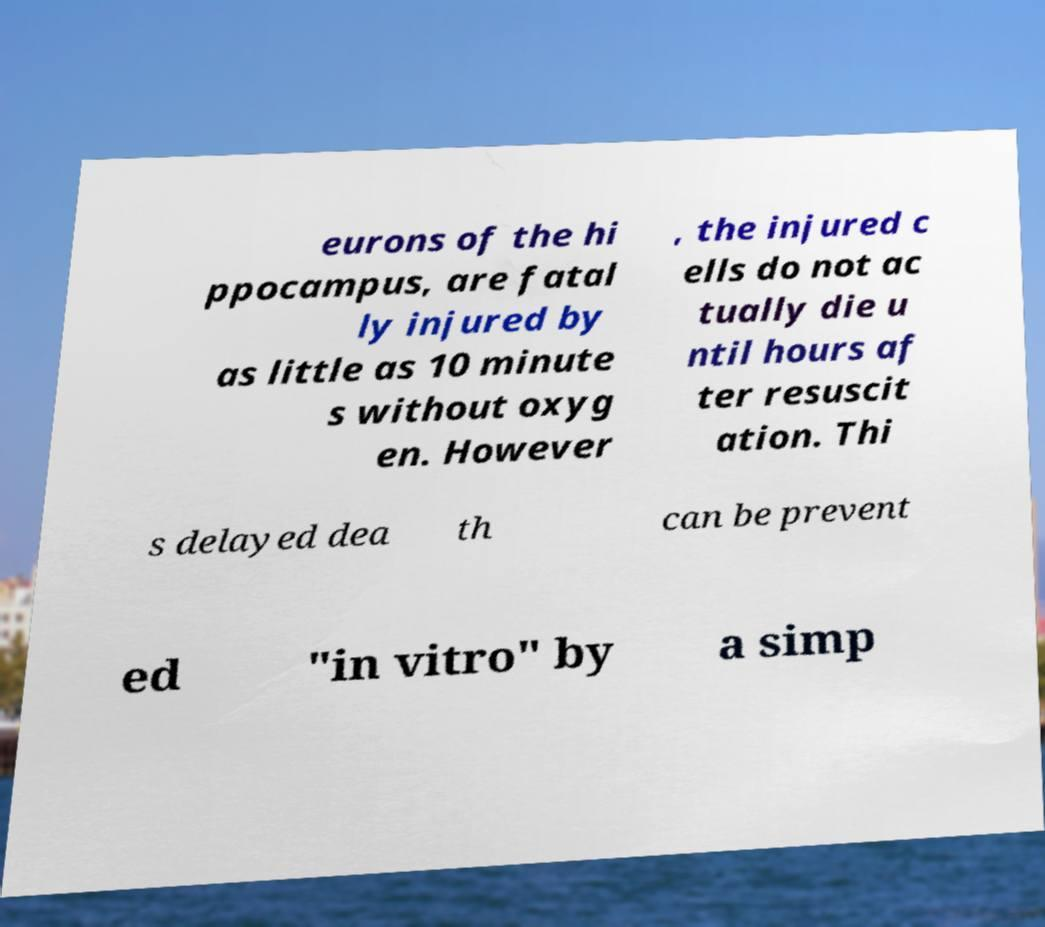Could you assist in decoding the text presented in this image and type it out clearly? eurons of the hi ppocampus, are fatal ly injured by as little as 10 minute s without oxyg en. However , the injured c ells do not ac tually die u ntil hours af ter resuscit ation. Thi s delayed dea th can be prevent ed "in vitro" by a simp 